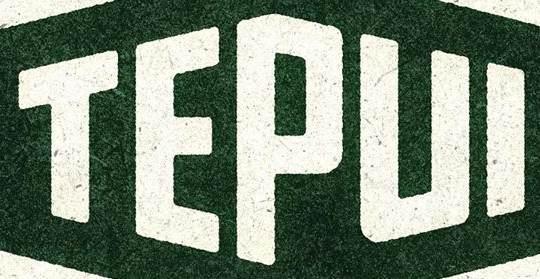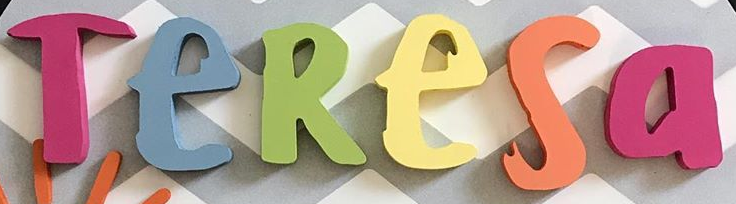Read the text from these images in sequence, separated by a semicolon. TEPUI; TeResa 